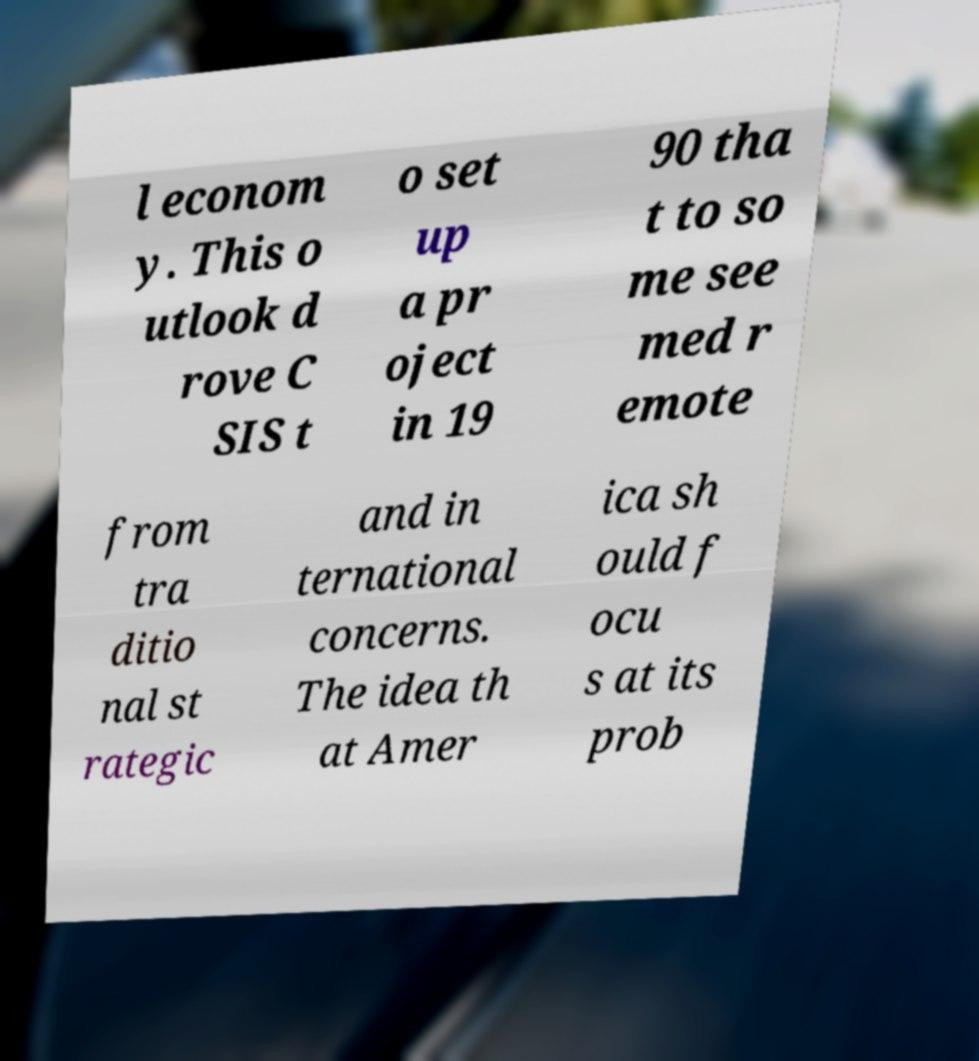Can you accurately transcribe the text from the provided image for me? l econom y. This o utlook d rove C SIS t o set up a pr oject in 19 90 tha t to so me see med r emote from tra ditio nal st rategic and in ternational concerns. The idea th at Amer ica sh ould f ocu s at its prob 